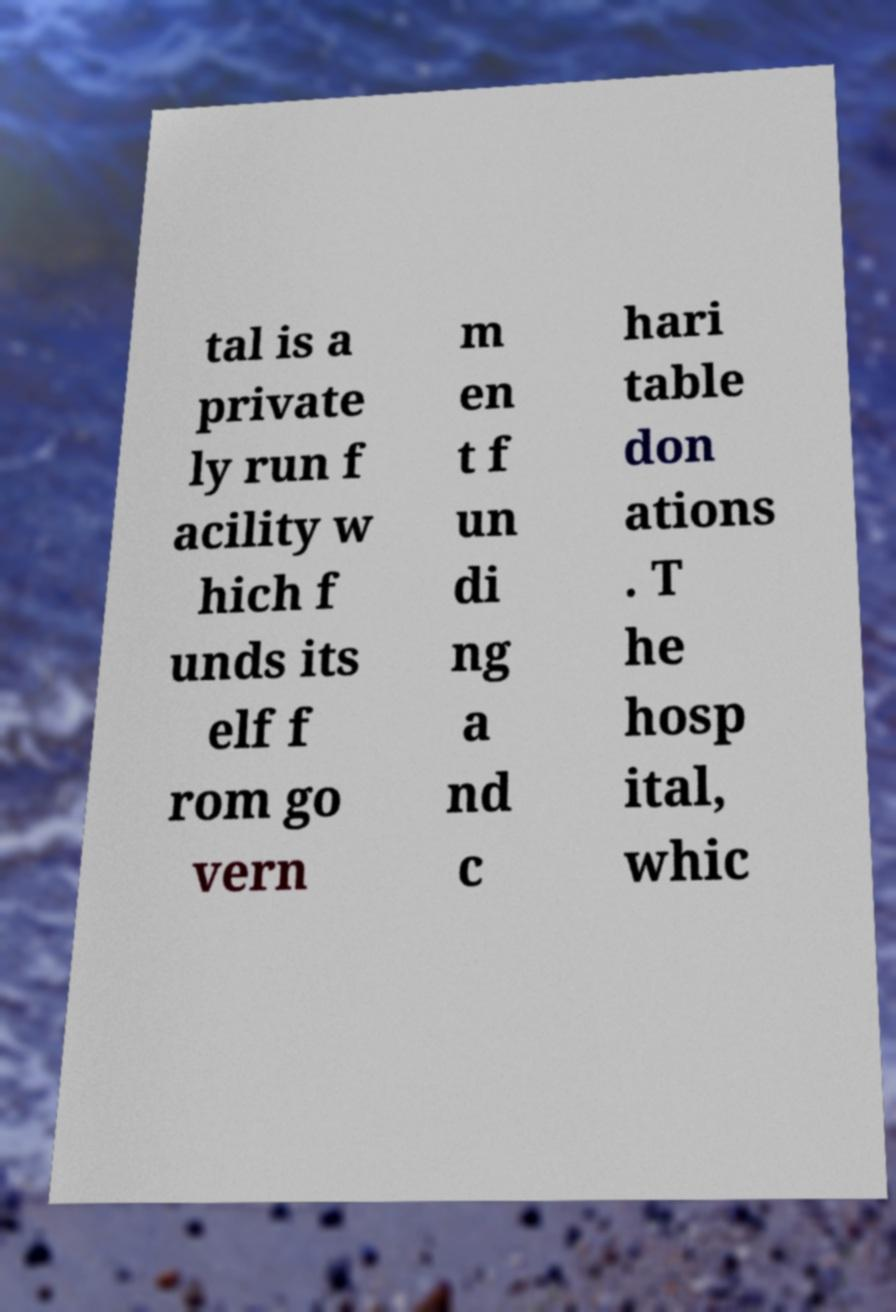Please identify and transcribe the text found in this image. tal is a private ly run f acility w hich f unds its elf f rom go vern m en t f un di ng a nd c hari table don ations . T he hosp ital, whic 